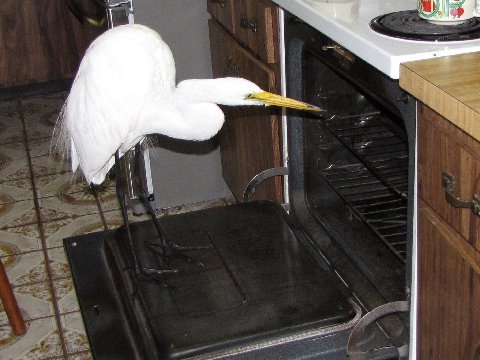Describe the objects in this image and their specific colors. I can see oven in black, gray, lightgray, and darkgray tones and bird in black, white, darkgray, and gray tones in this image. 